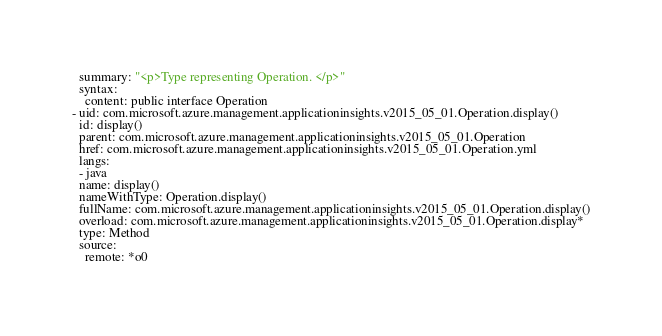Convert code to text. <code><loc_0><loc_0><loc_500><loc_500><_YAML_>  summary: "<p>Type representing Operation. </p>"
  syntax:
    content: public interface Operation
- uid: com.microsoft.azure.management.applicationinsights.v2015_05_01.Operation.display()
  id: display()
  parent: com.microsoft.azure.management.applicationinsights.v2015_05_01.Operation
  href: com.microsoft.azure.management.applicationinsights.v2015_05_01.Operation.yml
  langs:
  - java
  name: display()
  nameWithType: Operation.display()
  fullName: com.microsoft.azure.management.applicationinsights.v2015_05_01.Operation.display()
  overload: com.microsoft.azure.management.applicationinsights.v2015_05_01.Operation.display*
  type: Method
  source:
    remote: *o0</code> 